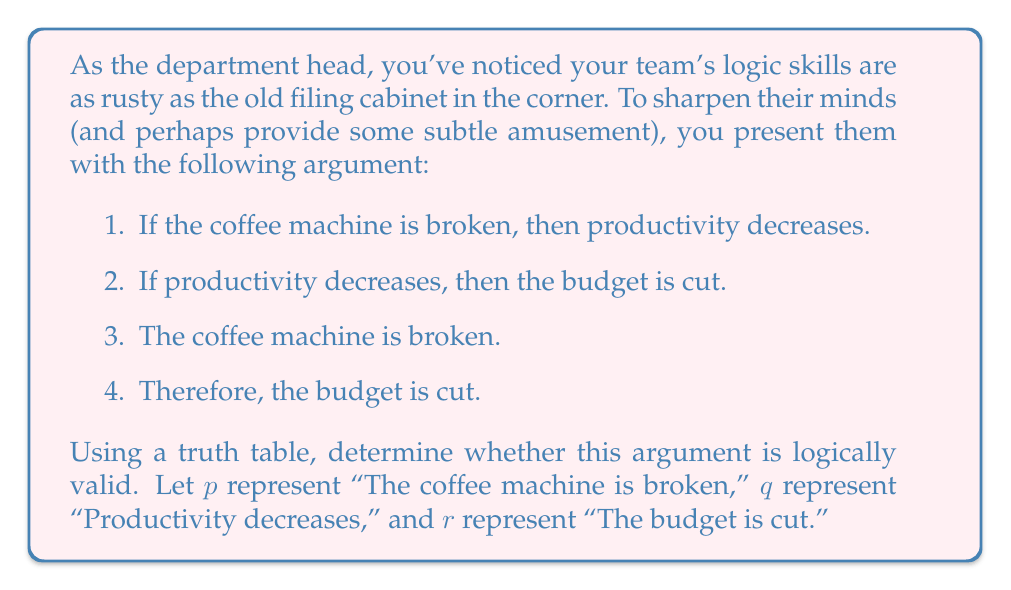What is the answer to this math problem? To determine the logical validity of this argument using a truth table, we need to evaluate all possible combinations of truth values for the premises and the conclusion. An argument is logically valid if, whenever all premises are true, the conclusion must also be true.

Let's construct the truth table:

1. First, we list all possible combinations of truth values for $p$, $q$, and $r$.
2. Then, we evaluate the premises:
   - Premise 1: $p \rightarrow q$
   - Premise 2: $q \rightarrow r$
   - Premise 3: $p$
3. Finally, we evaluate the conclusion: $r$

Here's the truth table:

$$
\begin{array}{|c|c|c||c|c|c||c|}
\hline
p & q & r & p \rightarrow q & q \rightarrow r & p & r \\
\hline
T & T & T & T & T & T & T \\
T & T & F & T & F & T & F \\
T & F & T & F & T & T & T \\
T & F & F & F & T & T & F \\
F & T & T & T & T & F & T \\
F & T & F & T & F & F & F \\
F & F & T & T & T & F & T \\
F & F & F & T & T & F & F \\
\hline
\end{array}
$$

To determine validity, we need to check if there's any row where all premises are true (T) but the conclusion is false (F).

The premises are all true only in the first row:
- $p \rightarrow q$ is T
- $q \rightarrow r$ is T
- $p$ is T

In this row, we see that the conclusion $r$ is also T.

Since there is no row where all premises are true and the conclusion is false, the argument is logically valid.
Answer: The argument is logically valid. 